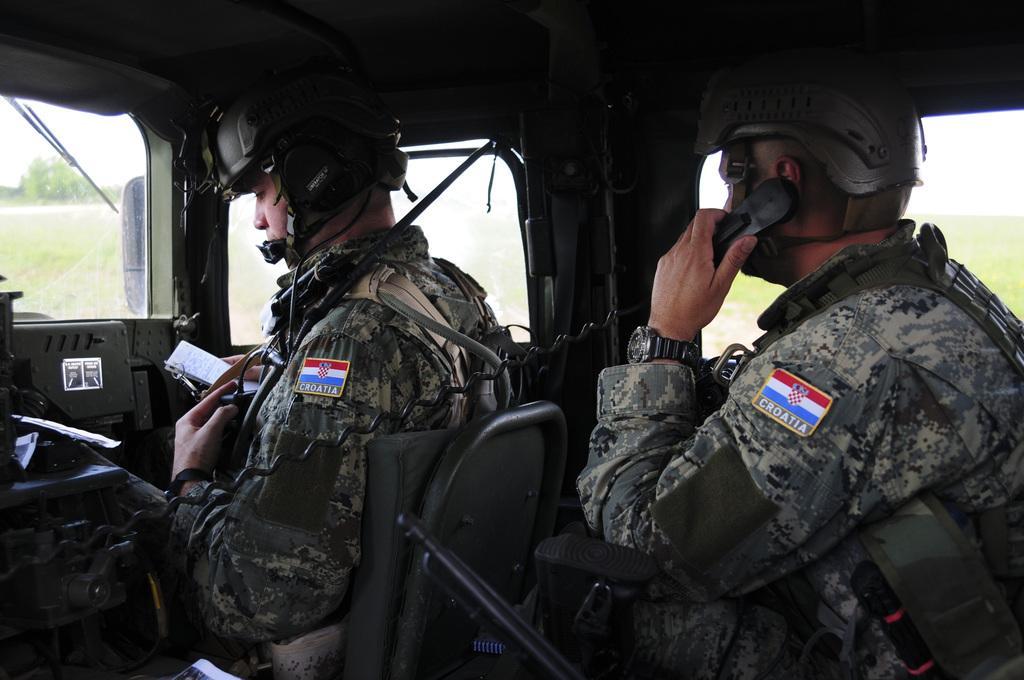Describe this image in one or two sentences. In this image there are persons sitting inside the vehicle and outside the windows there are trees. 